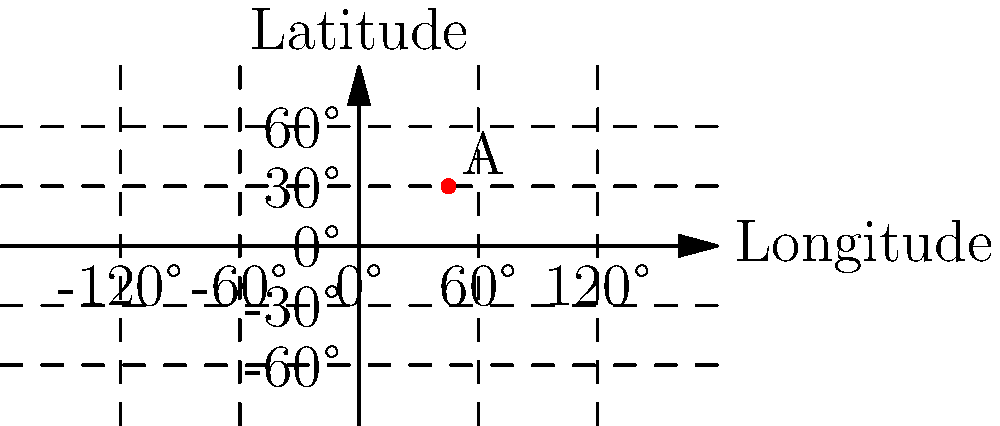In military operations, GPS coordinates are often converted to the Military Grid Reference System (MGRS) for tactical purposes. Given the GPS coordinates of point A (45°N, 45°E) shown on the map, what would be the first two characters of its corresponding MGRS grid zone designation? To determine the first two characters of the MGRS grid zone designation, we need to follow these steps:

1. Understand the MGRS system:
   - The world is divided into 6° wide longitude zones, numbered from 1 to 60, starting at 180°W.
   - Each zone is divided into 8° tall latitude bands, lettered from C to X (omitting I and O).

2. Determine the longitude zone:
   - The point is at 45°E.
   - Count the zones from 180°W: 180°W to 174°W is zone 1, 174°W to 168°W is zone 2, and so on.
   - 45°E falls in the 8th zone (42°E to 48°E).

3. Determine the latitude band:
   - The point is at 30°N.
   - Latitude bands start at 80°S and go up in 8° increments.
   - 30°N falls in the band from 24°N to 32°N, which corresponds to the letter "U".

4. Combine the results:
   - The longitude zone number is 38.
   - The latitude band letter is U.

Therefore, the first two characters of the MGRS grid zone designation for point A are 38U.
Answer: 38U 